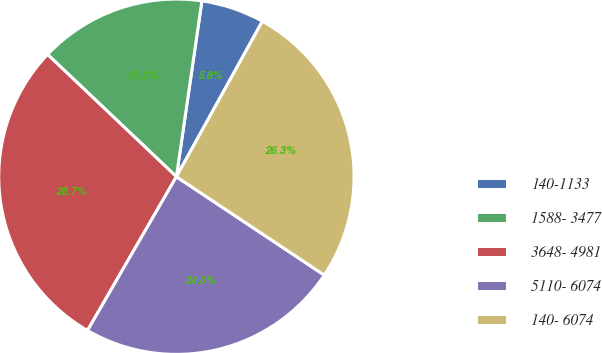Convert chart to OTSL. <chart><loc_0><loc_0><loc_500><loc_500><pie_chart><fcel>140-1133<fcel>1588- 3477<fcel>3648- 4981<fcel>5110- 6074<fcel>140- 6074<nl><fcel>5.75%<fcel>15.21%<fcel>28.74%<fcel>24.0%<fcel>26.3%<nl></chart> 